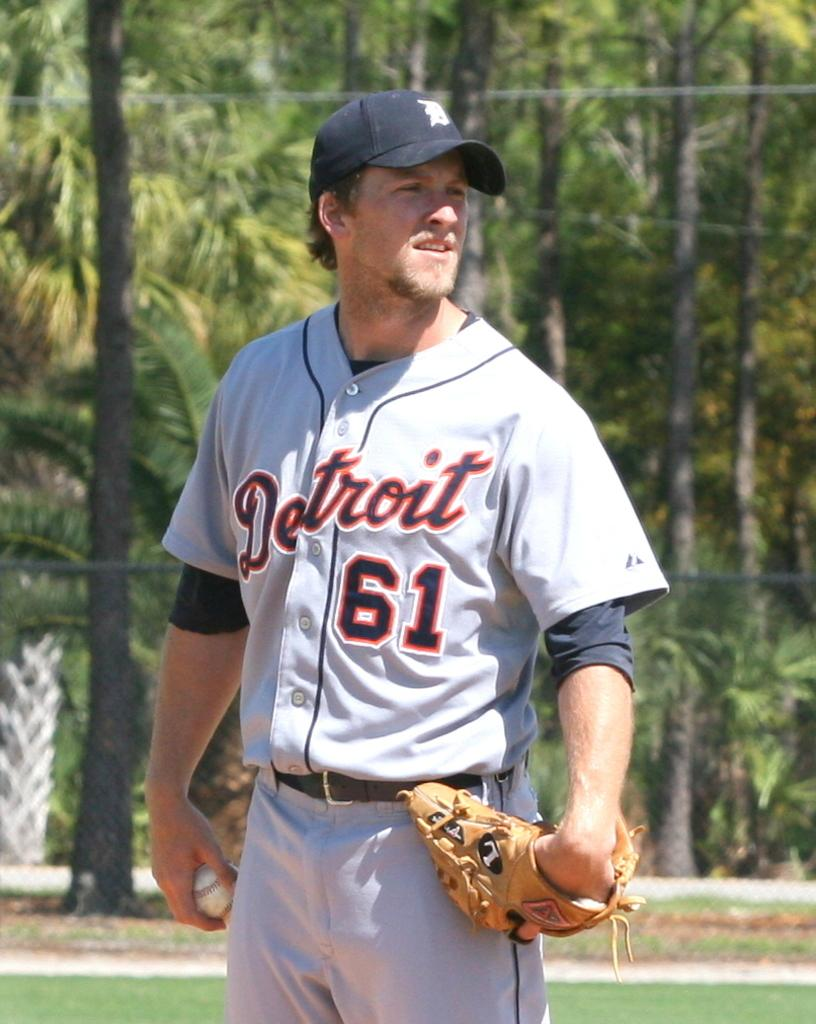<image>
Render a clear and concise summary of the photo. A Detroit player wearing 61 standing on a field. 